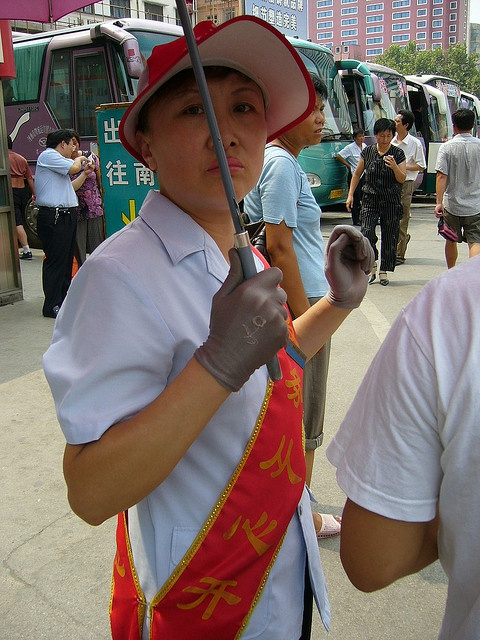Describe the objects in this image and their specific colors. I can see people in purple, darkgray, maroon, and gray tones, people in purple, darkgray, gray, and maroon tones, bus in purple, black, teal, gray, and lightgray tones, people in purple, maroon, and gray tones, and people in purple, black, darkgray, and gray tones in this image. 